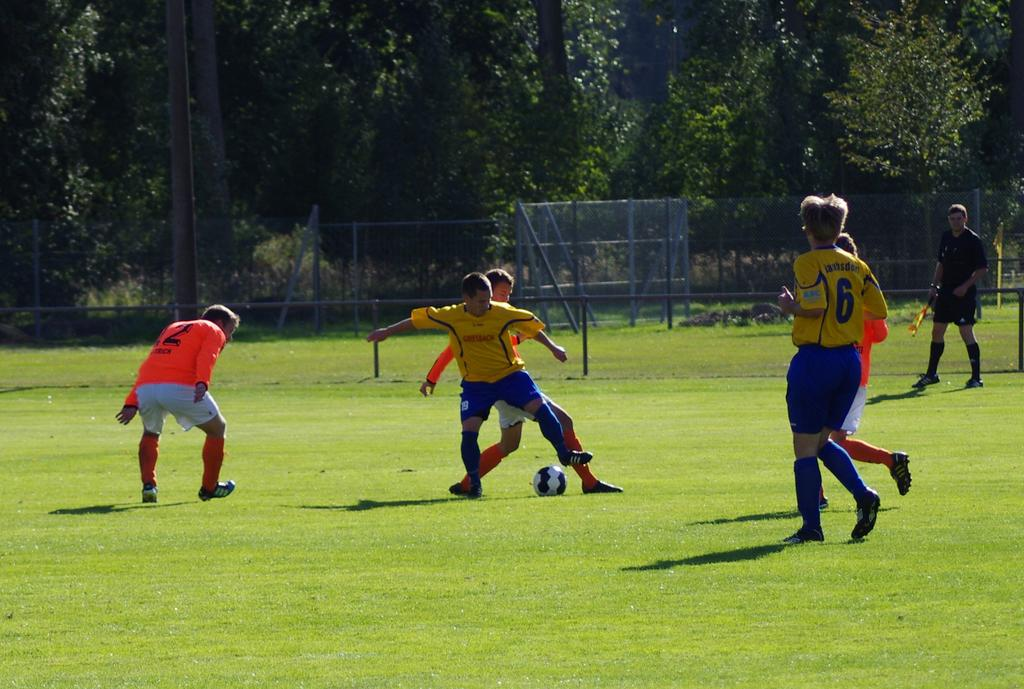<image>
Create a compact narrative representing the image presented. a soccer playere approaching the ball with the number six on the back of their jersey 